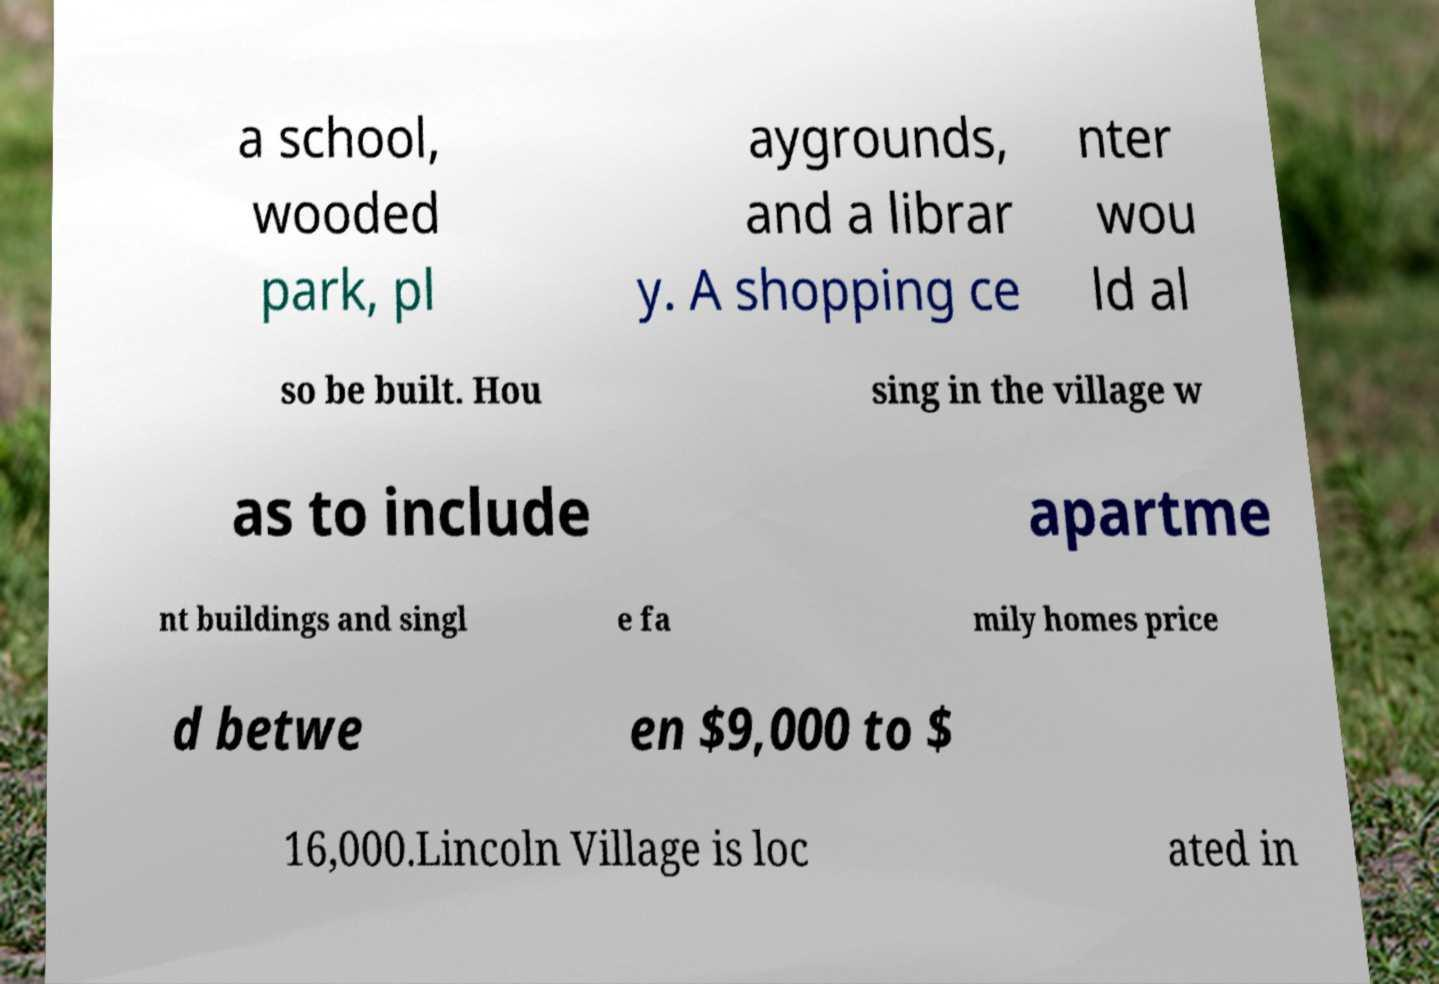I need the written content from this picture converted into text. Can you do that? a school, wooded park, pl aygrounds, and a librar y. A shopping ce nter wou ld al so be built. Hou sing in the village w as to include apartme nt buildings and singl e fa mily homes price d betwe en $9,000 to $ 16,000.Lincoln Village is loc ated in 